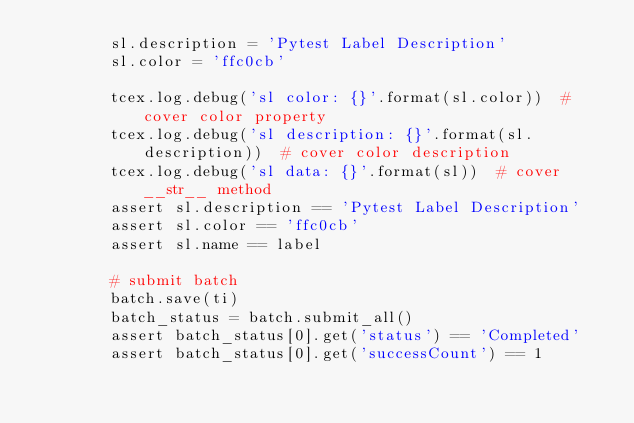<code> <loc_0><loc_0><loc_500><loc_500><_Python_>        sl.description = 'Pytest Label Description'
        sl.color = 'ffc0cb'

        tcex.log.debug('sl color: {}'.format(sl.color))  # cover color property
        tcex.log.debug('sl description: {}'.format(sl.description))  # cover color description
        tcex.log.debug('sl data: {}'.format(sl))  # cover __str__ method
        assert sl.description == 'Pytest Label Description'
        assert sl.color == 'ffc0cb'
        assert sl.name == label

        # submit batch
        batch.save(ti)
        batch_status = batch.submit_all()
        assert batch_status[0].get('status') == 'Completed'
        assert batch_status[0].get('successCount') == 1
</code> 